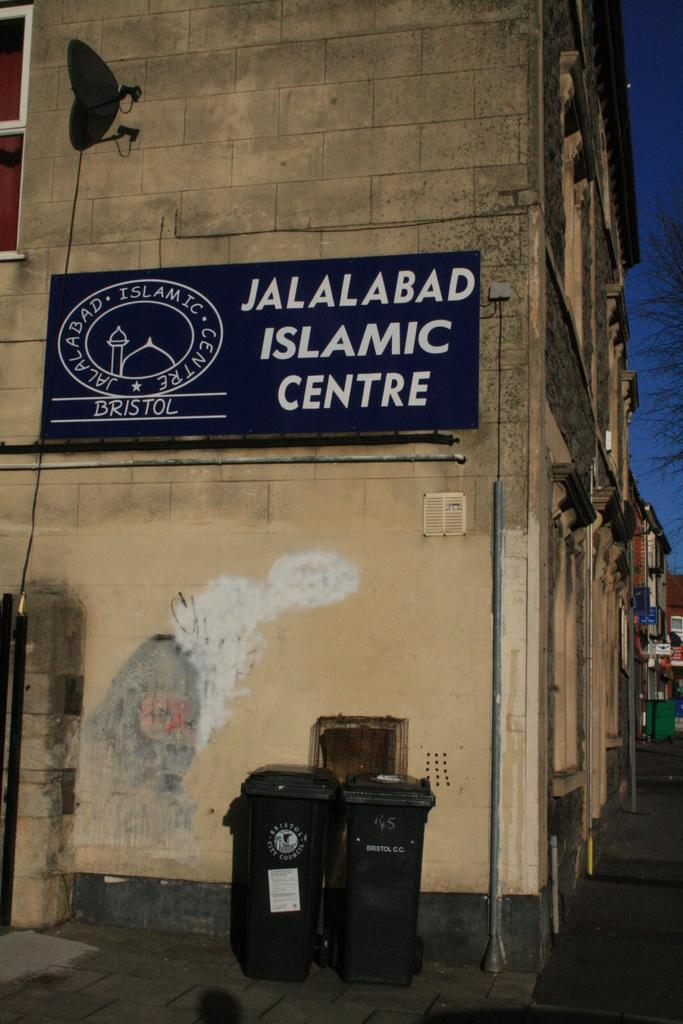<image>
Summarize the visual content of the image. Rectangular sign that says Jalalabad Islamic Centre on a brick building. 